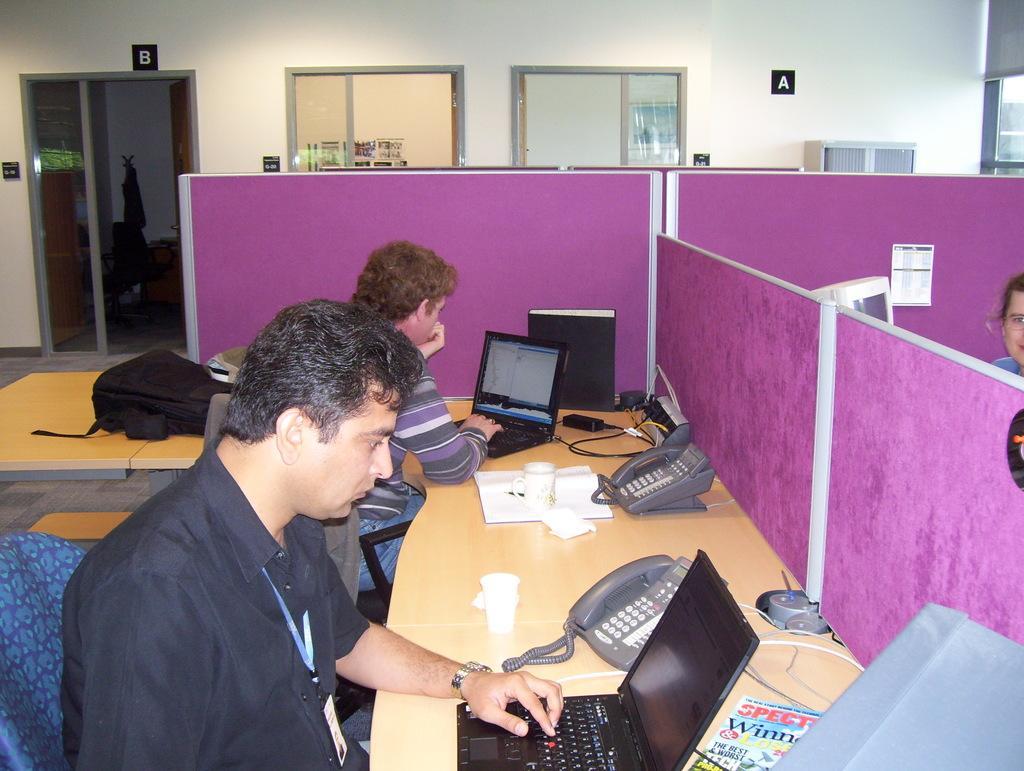In one or two sentences, can you explain what this image depicts? In this picture we can see two persons sitting on the chairs. This is table. On the table there a laptop, telephone, cup, and a paper. This is the bag. On the background we can see a door and this is the wall. 